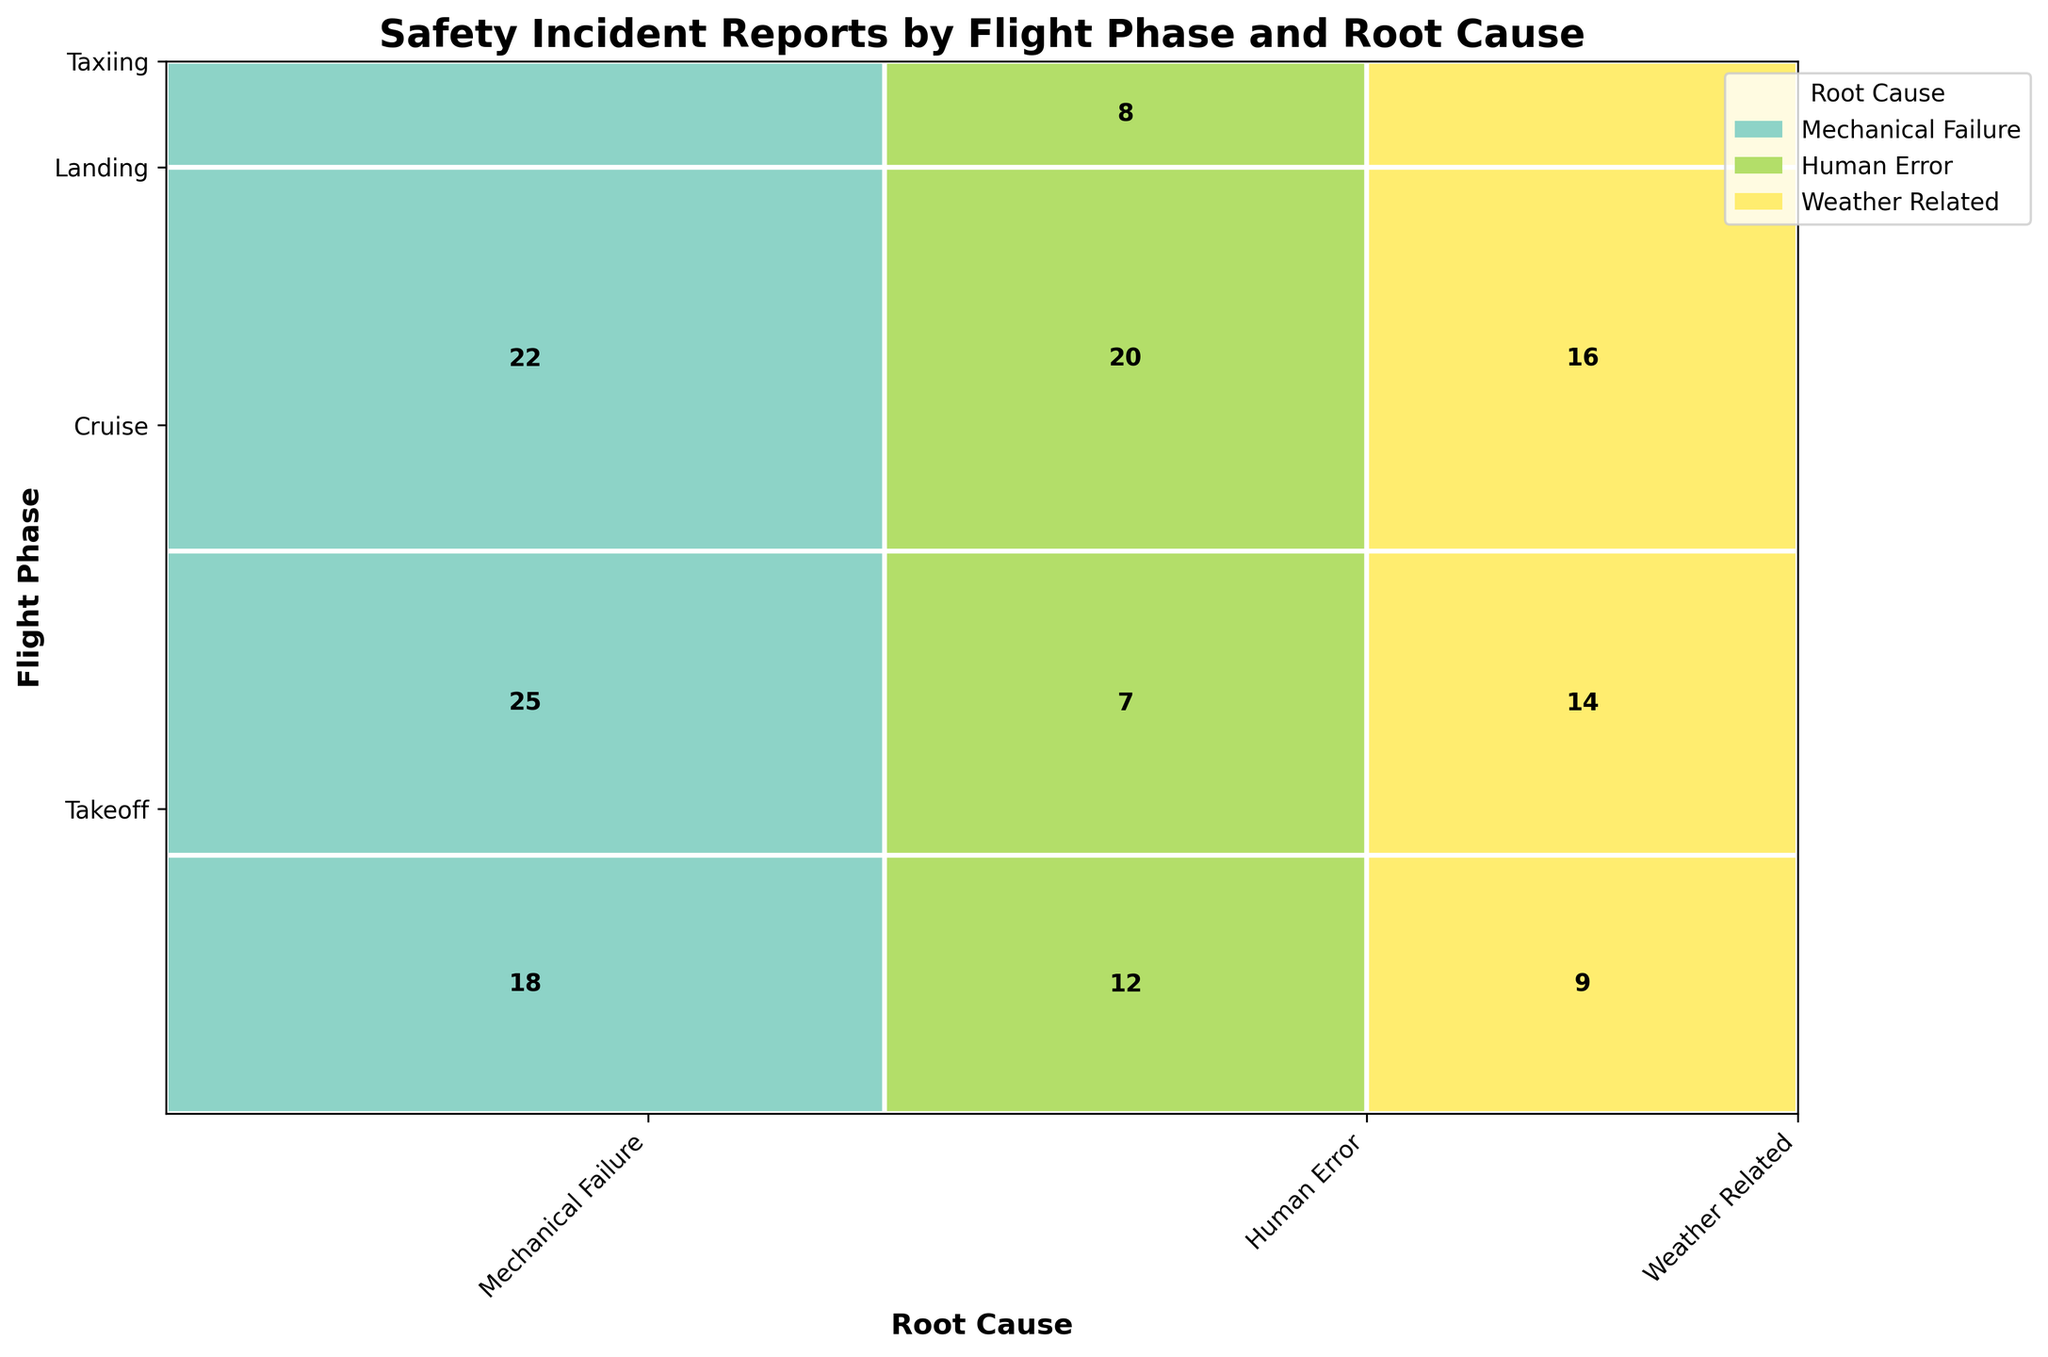What does the title of the plot indicate? The title of the plot "Safety Incident Reports by Flight Phase and Root Cause" indicates that the plot provides information on the number of safety incidents categorized by the different phases of flight (like Takeoff, Cruise, Landing, and Taxiing) and the root causes of those incidents (like Mechanical Failure, Human Error, and Weather Related).
Answer: Safety Incident Reports by Flight Phase and Root Cause How is the data categorized on the X-axis and Y-axis? The X-axis categorizes the data based on the root cause of the incidents (Mechanical Failure, Human Error, and Weather Related), and the Y-axis categorizes the data based on the flight phase in which the incidents occurred (Takeoff, Cruise, Landing, and Taxiing).
Answer: The X-axis is for root cause, and the Y-axis is for flight phase Which root cause has the highest number of incidents during the Cruise phase? Look at the section of the Mosaic Plot corresponding to the Cruise phase on the Y-axis and identify the root cause with the largest rectangle. The color representing Mechanical Failure covers the largest area for the Cruise phase.
Answer: Mechanical Failure Compare the number of incidents caused by Human Error during Takeoff and Landing phases. Which phase has more incidents? Locate the sections of the Mosaic Plot for Human Error in both the Takeoff and Landing phases. The rectangle for Human Error in the Landing phase is larger than in the Takeoff phase.
Answer: Landing phase What is the total number of incidents reported during Takeoff? Sum the individual numbers of incidents for each root cause during the Takeoff phase as presented in the plot: 18 (Mechanical Failure) + 12 (Human Error) + 9 (Weather Related).
Answer: 39 What is the proportion of Mechanical Failure incidents during the Landing phase compared to the total incidents in the Landing phase? Calculate the proportion by dividing the number of Mechanical Failure incidents during Landing (22) by the total number of incidents during Landing. The total incidents during Landing are 22 (Mechanical Failure) + 20 (Human Error) + 16 (Weather Related) = 58. Then the proportion is 22/58.
Answer: 22/58 Compare the total number of incidents caused by Weather Related issues to those caused by Human Error. Which cause has more incidents? Sum the total number of incidents due to Weather Related (9 for Takeoff + 14 for Cruise + 16 for Landing + 3 for Taxiing) and compare it to the sum of total incidents due to Human Error (12 for Takeoff + 7 for Cruise + 20 for Landing + 8 for Taxiing).
Answer: Human Error Which flight phase consistently has incidents attributed to each root cause? Observe the Mosaic Plot to see if each flight phase (Takeoff, Cruise, Landing, Taxiing) has a section for every root cause (Mechanical Failure, Human Error, Weather Related). Each flight phase indeed has incidents for every root cause.
Answer: All phases (Takeoff, Cruise, Landing, Taxiing) Does the plot show more incidents related to Mechanical Failure during Takeoff or Cruise? Compare the rectangles corresponding to Mechanical Failure in the Takeoff and Cruise phases. The rectangle for Cruise is larger.
Answer: Cruise 